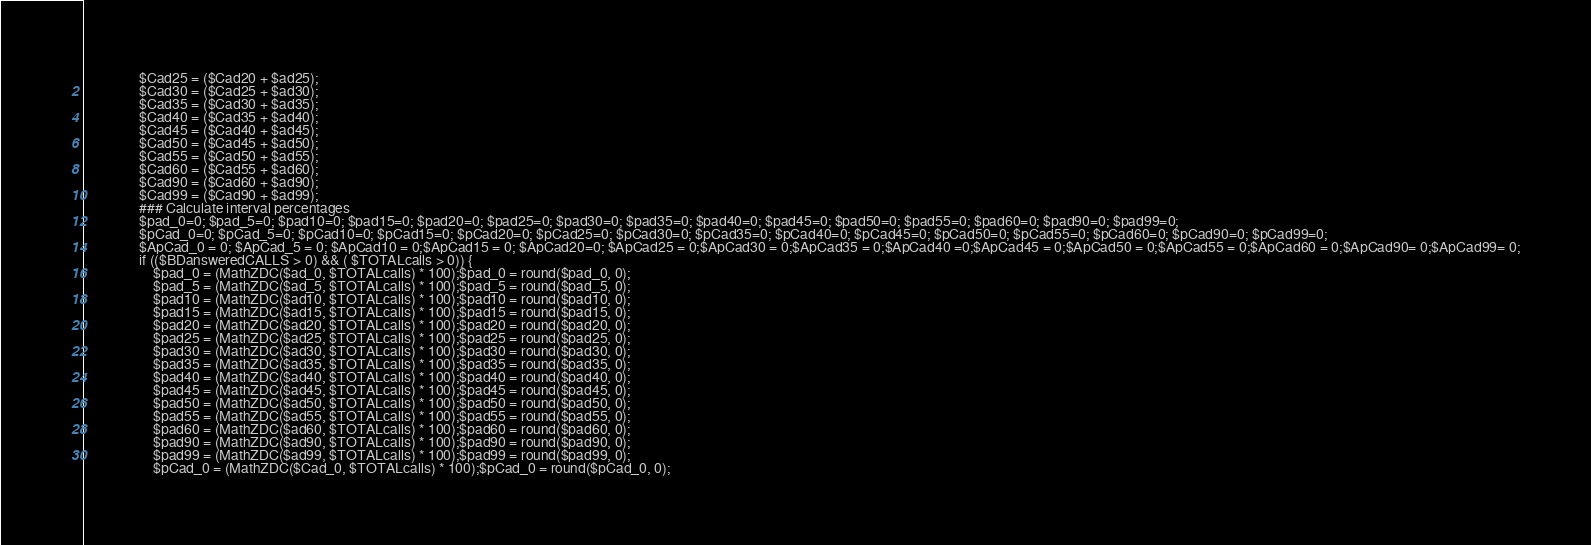Convert code to text. <code><loc_0><loc_0><loc_500><loc_500><_PHP_>                $Cad25 = ($Cad20 + $ad25);
                $Cad30 = ($Cad25 + $ad30);
                $Cad35 = ($Cad30 + $ad35);
                $Cad40 = ($Cad35 + $ad40);
                $Cad45 = ($Cad40 + $ad45);
                $Cad50 = ($Cad45 + $ad50);
                $Cad55 = ($Cad50 + $ad55);
                $Cad60 = ($Cad55 + $ad60);
                $Cad90 = ($Cad60 + $ad90);
                $Cad99 = ($Cad90 + $ad99);
                ### Calculate interval percentages
                $pad_0=0; $pad_5=0; $pad10=0; $pad15=0; $pad20=0; $pad25=0; $pad30=0; $pad35=0; $pad40=0; $pad45=0; $pad50=0; $pad55=0; $pad60=0; $pad90=0; $pad99=0;
                $pCad_0=0; $pCad_5=0; $pCad10=0; $pCad15=0; $pCad20=0; $pCad25=0; $pCad30=0; $pCad35=0; $pCad40=0; $pCad45=0; $pCad50=0; $pCad55=0; $pCad60=0; $pCad90=0; $pCad99=0;
                $ApCad_0 = 0; $ApCad_5 = 0; $ApCad10 = 0;$ApCad15 = 0; $ApCad20=0; $ApCad25 = 0;$ApCad30 = 0;$ApCad35 = 0;$ApCad40 =0;$ApCad45 = 0;$ApCad50 = 0;$ApCad55 = 0;$ApCad60 = 0;$ApCad90= 0;$ApCad99= 0;
                if (($BDansweredCALLS > 0) && ( $TOTALcalls > 0)) {
                    $pad_0 = (MathZDC($ad_0, $TOTALcalls) * 100);$pad_0 = round($pad_0, 0);
                    $pad_5 = (MathZDC($ad_5, $TOTALcalls) * 100);$pad_5 = round($pad_5, 0);
                    $pad10 = (MathZDC($ad10, $TOTALcalls) * 100);$pad10 = round($pad10, 0);
                    $pad15 = (MathZDC($ad15, $TOTALcalls) * 100);$pad15 = round($pad15, 0);
                    $pad20 = (MathZDC($ad20, $TOTALcalls) * 100);$pad20 = round($pad20, 0);
                    $pad25 = (MathZDC($ad25, $TOTALcalls) * 100);$pad25 = round($pad25, 0);
                    $pad30 = (MathZDC($ad30, $TOTALcalls) * 100);$pad30 = round($pad30, 0);
                    $pad35 = (MathZDC($ad35, $TOTALcalls) * 100);$pad35 = round($pad35, 0);
                    $pad40 = (MathZDC($ad40, $TOTALcalls) * 100);$pad40 = round($pad40, 0);
                    $pad45 = (MathZDC($ad45, $TOTALcalls) * 100);$pad45 = round($pad45, 0);
                    $pad50 = (MathZDC($ad50, $TOTALcalls) * 100);$pad50 = round($pad50, 0);
                    $pad55 = (MathZDC($ad55, $TOTALcalls) * 100);$pad55 = round($pad55, 0);
                    $pad60 = (MathZDC($ad60, $TOTALcalls) * 100);$pad60 = round($pad60, 0);
                    $pad90 = (MathZDC($ad90, $TOTALcalls) * 100);$pad90 = round($pad90, 0);
                    $pad99 = (MathZDC($ad99, $TOTALcalls) * 100);$pad99 = round($pad99, 0);
                    $pCad_0 = (MathZDC($Cad_0, $TOTALcalls) * 100);$pCad_0 = round($pCad_0, 0);</code> 